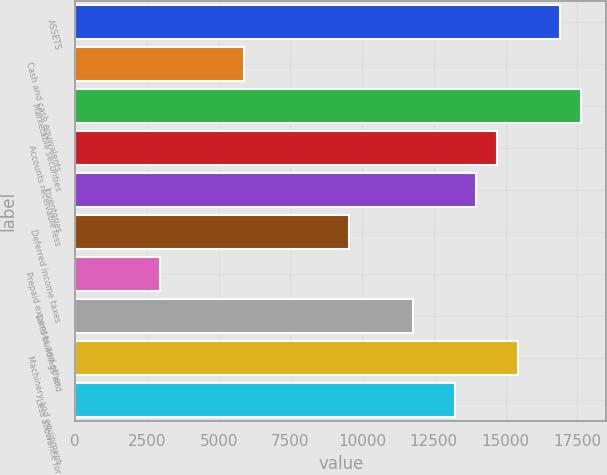<chart> <loc_0><loc_0><loc_500><loc_500><bar_chart><fcel>ASSETS<fcel>Cash and cash equivalents<fcel>Marketable securities<fcel>Accounts receivable less<fcel>Inventories<fcel>Deferred income taxes<fcel>Prepaid expenses and other<fcel>Land buildings and<fcel>Machinery and equipment<fcel>Less allowance for<nl><fcel>16892.4<fcel>5886.56<fcel>17626.1<fcel>14691.2<fcel>13957.5<fcel>9555.16<fcel>2951.68<fcel>11756.3<fcel>15424.9<fcel>13223.8<nl></chart> 